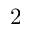Convert formula to latex. <formula><loc_0><loc_0><loc_500><loc_500>2</formula> 